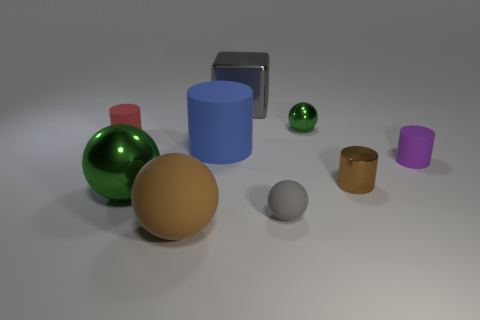What is the color of the other tiny thing that is the same shape as the gray rubber thing?
Your response must be concise. Green. Is there a big metallic object that has the same color as the cube?
Your answer should be very brief. No. How many gray balls are on the left side of the shiny cube?
Offer a very short reply. 0. What number of other objects are there of the same size as the blue cylinder?
Your answer should be compact. 3. Is the material of the gray thing in front of the tiny red object the same as the green thing to the left of the big block?
Provide a succinct answer. No. What is the color of the other matte cylinder that is the same size as the purple cylinder?
Your response must be concise. Red. Are there any other things of the same color as the big block?
Your answer should be compact. Yes. What is the size of the green metallic sphere that is behind the purple matte thing behind the metal thing in front of the small brown metallic object?
Your answer should be very brief. Small. What is the color of the shiny object that is both to the right of the large blue rubber cylinder and in front of the tiny red matte cylinder?
Offer a very short reply. Brown. What size is the green shiny object in front of the tiny purple rubber cylinder?
Give a very brief answer. Large. 